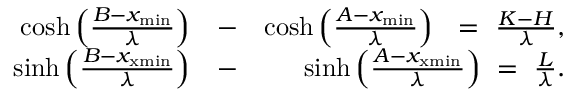Convert formula to latex. <formula><loc_0><loc_0><loc_500><loc_500>\begin{array} { r l r } { \cosh \left ( \frac { B - x _ { \min } } { \lambda } \right ) } & { - } & { \cosh \left ( \frac { A - x _ { \min } } { \lambda } \right ) = \frac { K - H } { \lambda } , } \\ { \sinh \left ( \frac { B - x _ { x \min } } { \lambda } \right ) } & { - } & { \sinh \left ( \frac { A - x _ { x \min } } { \lambda } \right ) = \frac { L } { \lambda } . } \end{array}</formula> 